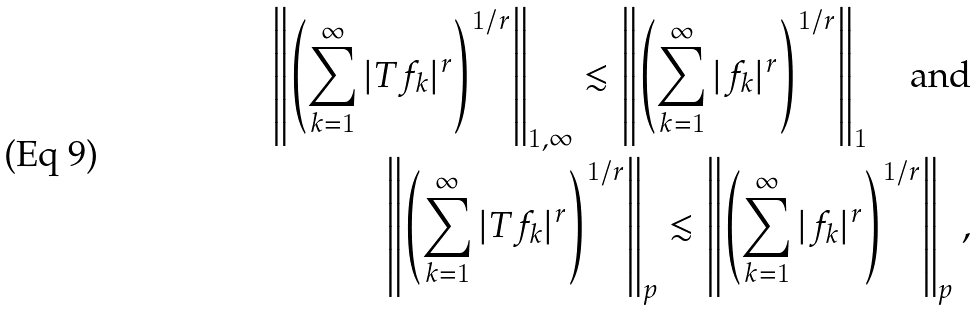<formula> <loc_0><loc_0><loc_500><loc_500>\left \| \left ( \sum _ { k = 1 } ^ { \infty } | T f _ { k } | ^ { r } \right ) ^ { 1 / r } \right \| _ { 1 , \infty } \lesssim \left \| \left ( \sum _ { k = 1 } ^ { \infty } | f _ { k } | ^ { r } \right ) ^ { 1 / r } \right \| _ { 1 } \quad \text {and} \\ \left \| \left ( \sum _ { k = 1 } ^ { \infty } | T f _ { k } | ^ { r } \right ) ^ { 1 / r } \right \| _ { p } \lesssim \left \| \left ( \sum _ { k = 1 } ^ { \infty } | f _ { k } | ^ { r } \right ) ^ { 1 / r } \right \| _ { p } ,</formula> 